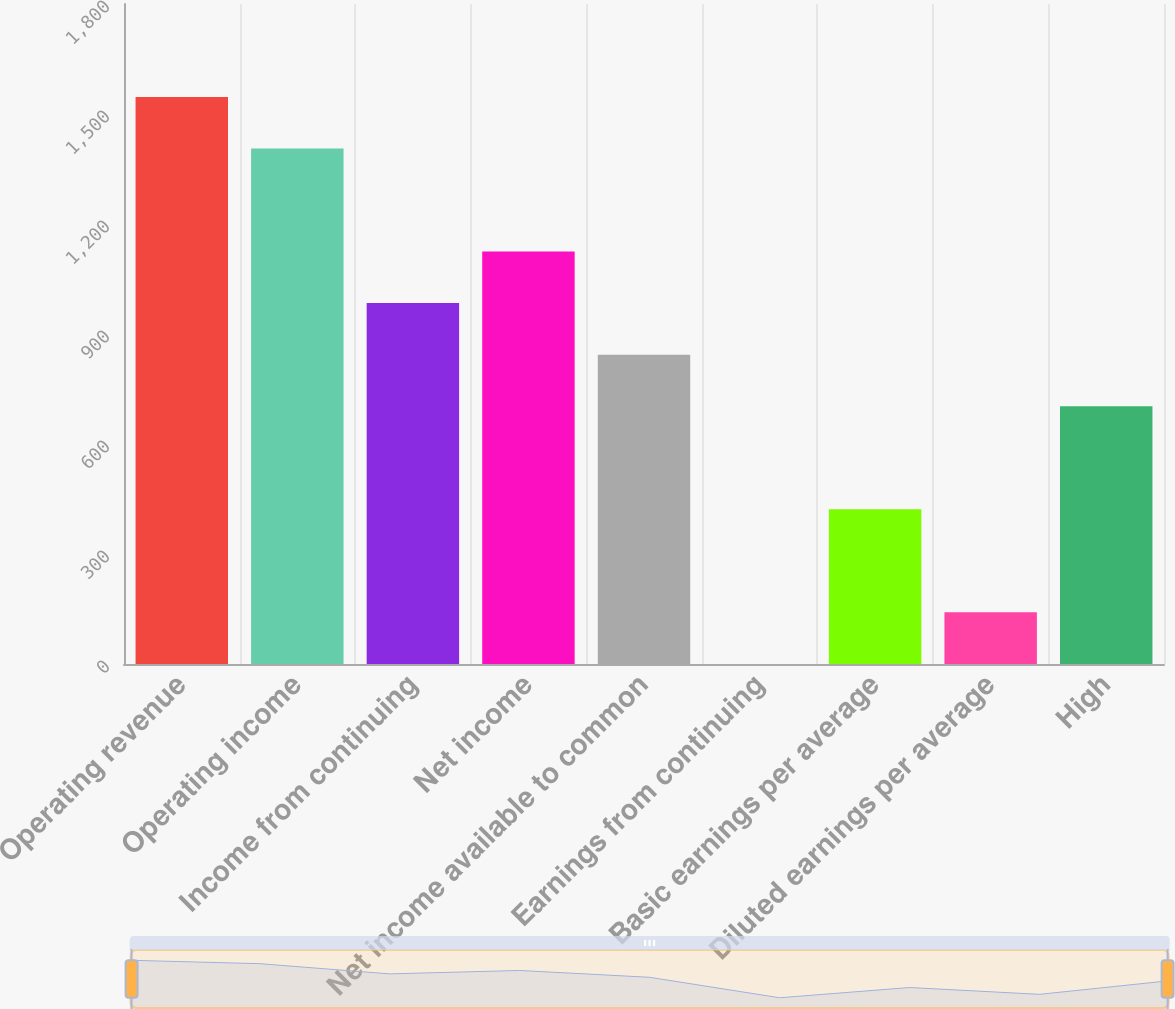<chart> <loc_0><loc_0><loc_500><loc_500><bar_chart><fcel>Operating revenue<fcel>Operating income<fcel>Income from continuing<fcel>Net income<fcel>Net income available to common<fcel>Earnings from continuing<fcel>Basic earnings per average<fcel>Diluted earnings per average<fcel>High<nl><fcel>1546.56<fcel>1405.99<fcel>984.28<fcel>1124.85<fcel>843.71<fcel>0.29<fcel>422<fcel>140.86<fcel>703.14<nl></chart> 